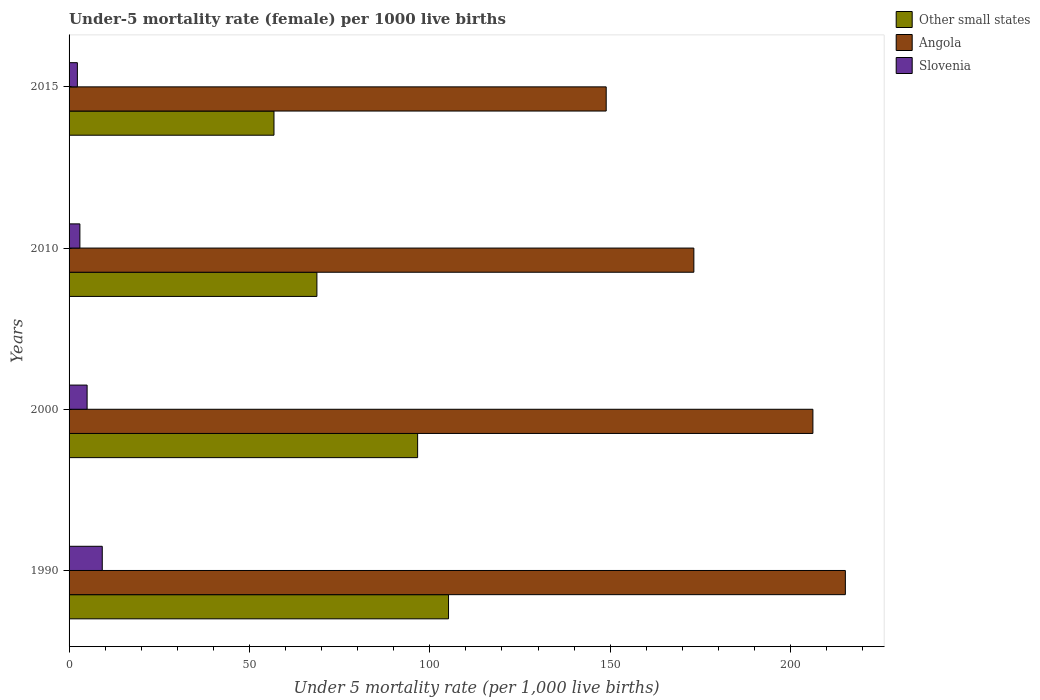Are the number of bars per tick equal to the number of legend labels?
Give a very brief answer. Yes. Across all years, what is the maximum under-five mortality rate in Slovenia?
Your response must be concise. 9.2. Across all years, what is the minimum under-five mortality rate in Other small states?
Ensure brevity in your answer.  56.81. In which year was the under-five mortality rate in Other small states maximum?
Offer a terse response. 1990. In which year was the under-five mortality rate in Slovenia minimum?
Give a very brief answer. 2015. What is the total under-five mortality rate in Slovenia in the graph?
Your answer should be compact. 19.5. What is the difference between the under-five mortality rate in Other small states in 1990 and that in 2000?
Your answer should be compact. 8.57. What is the difference between the under-five mortality rate in Angola in 2010 and the under-five mortality rate in Slovenia in 2000?
Your answer should be compact. 168.2. What is the average under-five mortality rate in Other small states per year?
Your response must be concise. 81.83. In the year 2015, what is the difference between the under-five mortality rate in Slovenia and under-five mortality rate in Other small states?
Your answer should be compact. -54.51. Is the under-five mortality rate in Other small states in 2010 less than that in 2015?
Give a very brief answer. No. What is the difference between the highest and the second highest under-five mortality rate in Slovenia?
Give a very brief answer. 4.2. What is the difference between the highest and the lowest under-five mortality rate in Slovenia?
Provide a short and direct response. 6.9. What does the 2nd bar from the top in 1990 represents?
Ensure brevity in your answer.  Angola. What does the 3rd bar from the bottom in 2010 represents?
Ensure brevity in your answer.  Slovenia. How many years are there in the graph?
Your response must be concise. 4. Are the values on the major ticks of X-axis written in scientific E-notation?
Your answer should be compact. No. Does the graph contain any zero values?
Make the answer very short. No. Does the graph contain grids?
Provide a short and direct response. No. How many legend labels are there?
Your answer should be very brief. 3. How are the legend labels stacked?
Make the answer very short. Vertical. What is the title of the graph?
Your answer should be compact. Under-5 mortality rate (female) per 1000 live births. Does "Seychelles" appear as one of the legend labels in the graph?
Provide a succinct answer. No. What is the label or title of the X-axis?
Keep it short and to the point. Under 5 mortality rate (per 1,0 live births). What is the label or title of the Y-axis?
Provide a succinct answer. Years. What is the Under 5 mortality rate (per 1,000 live births) in Other small states in 1990?
Provide a short and direct response. 105.19. What is the Under 5 mortality rate (per 1,000 live births) of Angola in 1990?
Offer a terse response. 215.2. What is the Under 5 mortality rate (per 1,000 live births) in Slovenia in 1990?
Provide a short and direct response. 9.2. What is the Under 5 mortality rate (per 1,000 live births) of Other small states in 2000?
Ensure brevity in your answer.  96.62. What is the Under 5 mortality rate (per 1,000 live births) of Angola in 2000?
Offer a very short reply. 206.2. What is the Under 5 mortality rate (per 1,000 live births) in Slovenia in 2000?
Provide a succinct answer. 5. What is the Under 5 mortality rate (per 1,000 live births) in Other small states in 2010?
Provide a succinct answer. 68.7. What is the Under 5 mortality rate (per 1,000 live births) of Angola in 2010?
Your answer should be very brief. 173.2. What is the Under 5 mortality rate (per 1,000 live births) in Other small states in 2015?
Your response must be concise. 56.81. What is the Under 5 mortality rate (per 1,000 live births) of Angola in 2015?
Ensure brevity in your answer.  148.9. What is the Under 5 mortality rate (per 1,000 live births) of Slovenia in 2015?
Provide a short and direct response. 2.3. Across all years, what is the maximum Under 5 mortality rate (per 1,000 live births) of Other small states?
Your answer should be very brief. 105.19. Across all years, what is the maximum Under 5 mortality rate (per 1,000 live births) in Angola?
Give a very brief answer. 215.2. Across all years, what is the minimum Under 5 mortality rate (per 1,000 live births) of Other small states?
Offer a terse response. 56.81. Across all years, what is the minimum Under 5 mortality rate (per 1,000 live births) in Angola?
Keep it short and to the point. 148.9. Across all years, what is the minimum Under 5 mortality rate (per 1,000 live births) in Slovenia?
Your response must be concise. 2.3. What is the total Under 5 mortality rate (per 1,000 live births) of Other small states in the graph?
Provide a succinct answer. 327.33. What is the total Under 5 mortality rate (per 1,000 live births) in Angola in the graph?
Give a very brief answer. 743.5. What is the difference between the Under 5 mortality rate (per 1,000 live births) in Other small states in 1990 and that in 2000?
Provide a short and direct response. 8.57. What is the difference between the Under 5 mortality rate (per 1,000 live births) of Other small states in 1990 and that in 2010?
Your answer should be compact. 36.49. What is the difference between the Under 5 mortality rate (per 1,000 live births) in Angola in 1990 and that in 2010?
Make the answer very short. 42. What is the difference between the Under 5 mortality rate (per 1,000 live births) in Slovenia in 1990 and that in 2010?
Provide a short and direct response. 6.2. What is the difference between the Under 5 mortality rate (per 1,000 live births) of Other small states in 1990 and that in 2015?
Offer a very short reply. 48.38. What is the difference between the Under 5 mortality rate (per 1,000 live births) of Angola in 1990 and that in 2015?
Your response must be concise. 66.3. What is the difference between the Under 5 mortality rate (per 1,000 live births) of Other small states in 2000 and that in 2010?
Your answer should be very brief. 27.92. What is the difference between the Under 5 mortality rate (per 1,000 live births) in Other small states in 2000 and that in 2015?
Ensure brevity in your answer.  39.82. What is the difference between the Under 5 mortality rate (per 1,000 live births) in Angola in 2000 and that in 2015?
Offer a terse response. 57.3. What is the difference between the Under 5 mortality rate (per 1,000 live births) in Other small states in 2010 and that in 2015?
Give a very brief answer. 11.9. What is the difference between the Under 5 mortality rate (per 1,000 live births) of Angola in 2010 and that in 2015?
Your response must be concise. 24.3. What is the difference between the Under 5 mortality rate (per 1,000 live births) of Other small states in 1990 and the Under 5 mortality rate (per 1,000 live births) of Angola in 2000?
Provide a succinct answer. -101.01. What is the difference between the Under 5 mortality rate (per 1,000 live births) in Other small states in 1990 and the Under 5 mortality rate (per 1,000 live births) in Slovenia in 2000?
Provide a succinct answer. 100.19. What is the difference between the Under 5 mortality rate (per 1,000 live births) in Angola in 1990 and the Under 5 mortality rate (per 1,000 live births) in Slovenia in 2000?
Keep it short and to the point. 210.2. What is the difference between the Under 5 mortality rate (per 1,000 live births) of Other small states in 1990 and the Under 5 mortality rate (per 1,000 live births) of Angola in 2010?
Make the answer very short. -68.01. What is the difference between the Under 5 mortality rate (per 1,000 live births) of Other small states in 1990 and the Under 5 mortality rate (per 1,000 live births) of Slovenia in 2010?
Offer a terse response. 102.19. What is the difference between the Under 5 mortality rate (per 1,000 live births) in Angola in 1990 and the Under 5 mortality rate (per 1,000 live births) in Slovenia in 2010?
Provide a succinct answer. 212.2. What is the difference between the Under 5 mortality rate (per 1,000 live births) in Other small states in 1990 and the Under 5 mortality rate (per 1,000 live births) in Angola in 2015?
Your answer should be compact. -43.71. What is the difference between the Under 5 mortality rate (per 1,000 live births) of Other small states in 1990 and the Under 5 mortality rate (per 1,000 live births) of Slovenia in 2015?
Offer a very short reply. 102.89. What is the difference between the Under 5 mortality rate (per 1,000 live births) in Angola in 1990 and the Under 5 mortality rate (per 1,000 live births) in Slovenia in 2015?
Ensure brevity in your answer.  212.9. What is the difference between the Under 5 mortality rate (per 1,000 live births) of Other small states in 2000 and the Under 5 mortality rate (per 1,000 live births) of Angola in 2010?
Your response must be concise. -76.58. What is the difference between the Under 5 mortality rate (per 1,000 live births) in Other small states in 2000 and the Under 5 mortality rate (per 1,000 live births) in Slovenia in 2010?
Keep it short and to the point. 93.62. What is the difference between the Under 5 mortality rate (per 1,000 live births) in Angola in 2000 and the Under 5 mortality rate (per 1,000 live births) in Slovenia in 2010?
Provide a succinct answer. 203.2. What is the difference between the Under 5 mortality rate (per 1,000 live births) of Other small states in 2000 and the Under 5 mortality rate (per 1,000 live births) of Angola in 2015?
Make the answer very short. -52.28. What is the difference between the Under 5 mortality rate (per 1,000 live births) of Other small states in 2000 and the Under 5 mortality rate (per 1,000 live births) of Slovenia in 2015?
Give a very brief answer. 94.32. What is the difference between the Under 5 mortality rate (per 1,000 live births) of Angola in 2000 and the Under 5 mortality rate (per 1,000 live births) of Slovenia in 2015?
Your answer should be very brief. 203.9. What is the difference between the Under 5 mortality rate (per 1,000 live births) of Other small states in 2010 and the Under 5 mortality rate (per 1,000 live births) of Angola in 2015?
Make the answer very short. -80.2. What is the difference between the Under 5 mortality rate (per 1,000 live births) of Other small states in 2010 and the Under 5 mortality rate (per 1,000 live births) of Slovenia in 2015?
Give a very brief answer. 66.4. What is the difference between the Under 5 mortality rate (per 1,000 live births) in Angola in 2010 and the Under 5 mortality rate (per 1,000 live births) in Slovenia in 2015?
Your response must be concise. 170.9. What is the average Under 5 mortality rate (per 1,000 live births) of Other small states per year?
Provide a succinct answer. 81.83. What is the average Under 5 mortality rate (per 1,000 live births) of Angola per year?
Offer a very short reply. 185.88. What is the average Under 5 mortality rate (per 1,000 live births) of Slovenia per year?
Your response must be concise. 4.88. In the year 1990, what is the difference between the Under 5 mortality rate (per 1,000 live births) in Other small states and Under 5 mortality rate (per 1,000 live births) in Angola?
Give a very brief answer. -110.01. In the year 1990, what is the difference between the Under 5 mortality rate (per 1,000 live births) of Other small states and Under 5 mortality rate (per 1,000 live births) of Slovenia?
Provide a succinct answer. 95.99. In the year 1990, what is the difference between the Under 5 mortality rate (per 1,000 live births) in Angola and Under 5 mortality rate (per 1,000 live births) in Slovenia?
Ensure brevity in your answer.  206. In the year 2000, what is the difference between the Under 5 mortality rate (per 1,000 live births) of Other small states and Under 5 mortality rate (per 1,000 live births) of Angola?
Give a very brief answer. -109.58. In the year 2000, what is the difference between the Under 5 mortality rate (per 1,000 live births) of Other small states and Under 5 mortality rate (per 1,000 live births) of Slovenia?
Keep it short and to the point. 91.62. In the year 2000, what is the difference between the Under 5 mortality rate (per 1,000 live births) in Angola and Under 5 mortality rate (per 1,000 live births) in Slovenia?
Your answer should be compact. 201.2. In the year 2010, what is the difference between the Under 5 mortality rate (per 1,000 live births) in Other small states and Under 5 mortality rate (per 1,000 live births) in Angola?
Keep it short and to the point. -104.5. In the year 2010, what is the difference between the Under 5 mortality rate (per 1,000 live births) in Other small states and Under 5 mortality rate (per 1,000 live births) in Slovenia?
Make the answer very short. 65.7. In the year 2010, what is the difference between the Under 5 mortality rate (per 1,000 live births) in Angola and Under 5 mortality rate (per 1,000 live births) in Slovenia?
Your response must be concise. 170.2. In the year 2015, what is the difference between the Under 5 mortality rate (per 1,000 live births) in Other small states and Under 5 mortality rate (per 1,000 live births) in Angola?
Your answer should be very brief. -92.09. In the year 2015, what is the difference between the Under 5 mortality rate (per 1,000 live births) in Other small states and Under 5 mortality rate (per 1,000 live births) in Slovenia?
Provide a short and direct response. 54.51. In the year 2015, what is the difference between the Under 5 mortality rate (per 1,000 live births) in Angola and Under 5 mortality rate (per 1,000 live births) in Slovenia?
Provide a succinct answer. 146.6. What is the ratio of the Under 5 mortality rate (per 1,000 live births) of Other small states in 1990 to that in 2000?
Provide a short and direct response. 1.09. What is the ratio of the Under 5 mortality rate (per 1,000 live births) of Angola in 1990 to that in 2000?
Provide a short and direct response. 1.04. What is the ratio of the Under 5 mortality rate (per 1,000 live births) in Slovenia in 1990 to that in 2000?
Offer a very short reply. 1.84. What is the ratio of the Under 5 mortality rate (per 1,000 live births) of Other small states in 1990 to that in 2010?
Offer a terse response. 1.53. What is the ratio of the Under 5 mortality rate (per 1,000 live births) in Angola in 1990 to that in 2010?
Offer a very short reply. 1.24. What is the ratio of the Under 5 mortality rate (per 1,000 live births) in Slovenia in 1990 to that in 2010?
Offer a very short reply. 3.07. What is the ratio of the Under 5 mortality rate (per 1,000 live births) in Other small states in 1990 to that in 2015?
Provide a short and direct response. 1.85. What is the ratio of the Under 5 mortality rate (per 1,000 live births) in Angola in 1990 to that in 2015?
Give a very brief answer. 1.45. What is the ratio of the Under 5 mortality rate (per 1,000 live births) of Other small states in 2000 to that in 2010?
Your response must be concise. 1.41. What is the ratio of the Under 5 mortality rate (per 1,000 live births) of Angola in 2000 to that in 2010?
Make the answer very short. 1.19. What is the ratio of the Under 5 mortality rate (per 1,000 live births) of Other small states in 2000 to that in 2015?
Make the answer very short. 1.7. What is the ratio of the Under 5 mortality rate (per 1,000 live births) of Angola in 2000 to that in 2015?
Offer a very short reply. 1.38. What is the ratio of the Under 5 mortality rate (per 1,000 live births) in Slovenia in 2000 to that in 2015?
Provide a short and direct response. 2.17. What is the ratio of the Under 5 mortality rate (per 1,000 live births) of Other small states in 2010 to that in 2015?
Provide a succinct answer. 1.21. What is the ratio of the Under 5 mortality rate (per 1,000 live births) of Angola in 2010 to that in 2015?
Offer a very short reply. 1.16. What is the ratio of the Under 5 mortality rate (per 1,000 live births) of Slovenia in 2010 to that in 2015?
Offer a very short reply. 1.3. What is the difference between the highest and the second highest Under 5 mortality rate (per 1,000 live births) of Other small states?
Your response must be concise. 8.57. What is the difference between the highest and the second highest Under 5 mortality rate (per 1,000 live births) of Angola?
Provide a short and direct response. 9. What is the difference between the highest and the lowest Under 5 mortality rate (per 1,000 live births) of Other small states?
Provide a succinct answer. 48.38. What is the difference between the highest and the lowest Under 5 mortality rate (per 1,000 live births) in Angola?
Make the answer very short. 66.3. What is the difference between the highest and the lowest Under 5 mortality rate (per 1,000 live births) in Slovenia?
Offer a terse response. 6.9. 